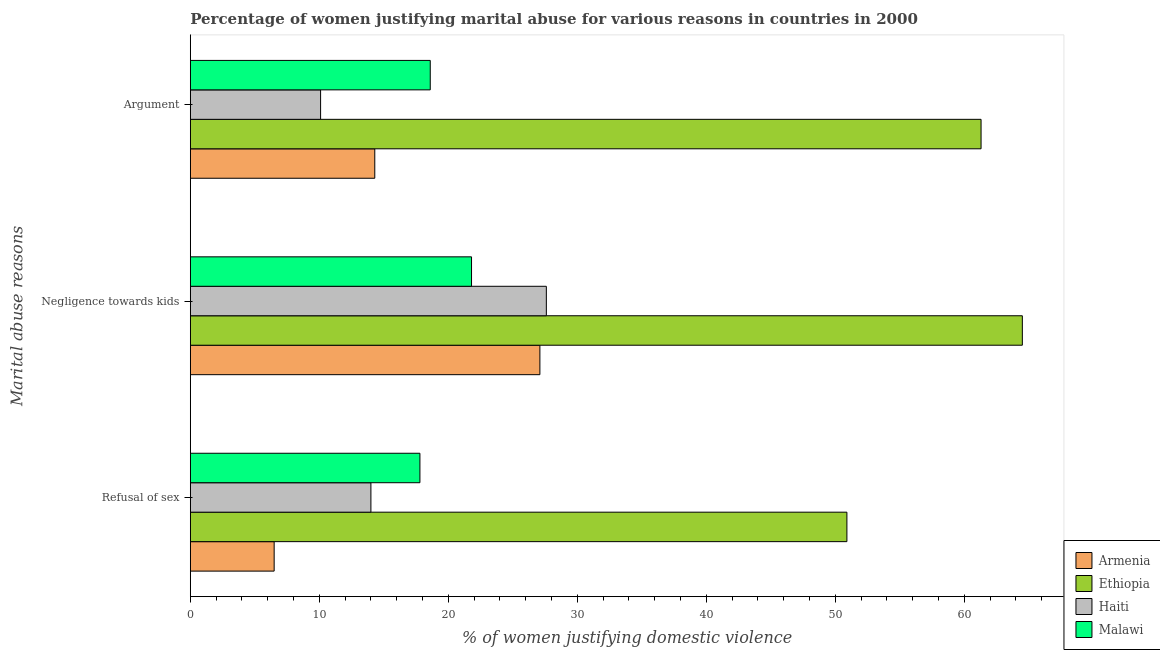How many different coloured bars are there?
Your answer should be very brief. 4. Are the number of bars per tick equal to the number of legend labels?
Offer a terse response. Yes. How many bars are there on the 2nd tick from the top?
Offer a terse response. 4. What is the label of the 1st group of bars from the top?
Provide a succinct answer. Argument. Across all countries, what is the maximum percentage of women justifying domestic violence due to refusal of sex?
Provide a succinct answer. 50.9. In which country was the percentage of women justifying domestic violence due to negligence towards kids maximum?
Your response must be concise. Ethiopia. In which country was the percentage of women justifying domestic violence due to arguments minimum?
Your response must be concise. Haiti. What is the total percentage of women justifying domestic violence due to arguments in the graph?
Provide a short and direct response. 104.3. What is the difference between the percentage of women justifying domestic violence due to refusal of sex in Ethiopia and that in Malawi?
Give a very brief answer. 33.1. What is the difference between the percentage of women justifying domestic violence due to refusal of sex in Haiti and the percentage of women justifying domestic violence due to arguments in Armenia?
Provide a short and direct response. -0.3. What is the average percentage of women justifying domestic violence due to refusal of sex per country?
Offer a terse response. 22.3. What is the difference between the percentage of women justifying domestic violence due to refusal of sex and percentage of women justifying domestic violence due to arguments in Ethiopia?
Keep it short and to the point. -10.4. In how many countries, is the percentage of women justifying domestic violence due to arguments greater than 16 %?
Your answer should be compact. 2. What is the ratio of the percentage of women justifying domestic violence due to arguments in Malawi to that in Haiti?
Your answer should be compact. 1.84. Is the difference between the percentage of women justifying domestic violence due to negligence towards kids in Armenia and Haiti greater than the difference between the percentage of women justifying domestic violence due to arguments in Armenia and Haiti?
Your response must be concise. No. What is the difference between the highest and the second highest percentage of women justifying domestic violence due to negligence towards kids?
Make the answer very short. 36.9. What is the difference between the highest and the lowest percentage of women justifying domestic violence due to refusal of sex?
Provide a succinct answer. 44.4. What does the 4th bar from the top in Negligence towards kids represents?
Make the answer very short. Armenia. What does the 3rd bar from the bottom in Argument represents?
Ensure brevity in your answer.  Haiti. Is it the case that in every country, the sum of the percentage of women justifying domestic violence due to refusal of sex and percentage of women justifying domestic violence due to negligence towards kids is greater than the percentage of women justifying domestic violence due to arguments?
Give a very brief answer. Yes. Are all the bars in the graph horizontal?
Make the answer very short. Yes. What is the difference between two consecutive major ticks on the X-axis?
Ensure brevity in your answer.  10. Does the graph contain grids?
Ensure brevity in your answer.  No. How are the legend labels stacked?
Offer a very short reply. Vertical. What is the title of the graph?
Your answer should be compact. Percentage of women justifying marital abuse for various reasons in countries in 2000. What is the label or title of the X-axis?
Your answer should be very brief. % of women justifying domestic violence. What is the label or title of the Y-axis?
Your answer should be very brief. Marital abuse reasons. What is the % of women justifying domestic violence in Armenia in Refusal of sex?
Keep it short and to the point. 6.5. What is the % of women justifying domestic violence of Ethiopia in Refusal of sex?
Keep it short and to the point. 50.9. What is the % of women justifying domestic violence in Armenia in Negligence towards kids?
Provide a succinct answer. 27.1. What is the % of women justifying domestic violence of Ethiopia in Negligence towards kids?
Provide a short and direct response. 64.5. What is the % of women justifying domestic violence in Haiti in Negligence towards kids?
Give a very brief answer. 27.6. What is the % of women justifying domestic violence of Malawi in Negligence towards kids?
Ensure brevity in your answer.  21.8. What is the % of women justifying domestic violence of Ethiopia in Argument?
Your answer should be compact. 61.3. What is the % of women justifying domestic violence in Haiti in Argument?
Ensure brevity in your answer.  10.1. What is the % of women justifying domestic violence of Malawi in Argument?
Provide a short and direct response. 18.6. Across all Marital abuse reasons, what is the maximum % of women justifying domestic violence of Armenia?
Your answer should be compact. 27.1. Across all Marital abuse reasons, what is the maximum % of women justifying domestic violence in Ethiopia?
Provide a succinct answer. 64.5. Across all Marital abuse reasons, what is the maximum % of women justifying domestic violence of Haiti?
Provide a succinct answer. 27.6. Across all Marital abuse reasons, what is the maximum % of women justifying domestic violence of Malawi?
Your response must be concise. 21.8. Across all Marital abuse reasons, what is the minimum % of women justifying domestic violence in Armenia?
Make the answer very short. 6.5. Across all Marital abuse reasons, what is the minimum % of women justifying domestic violence of Ethiopia?
Your response must be concise. 50.9. Across all Marital abuse reasons, what is the minimum % of women justifying domestic violence of Malawi?
Give a very brief answer. 17.8. What is the total % of women justifying domestic violence of Armenia in the graph?
Provide a short and direct response. 47.9. What is the total % of women justifying domestic violence in Ethiopia in the graph?
Make the answer very short. 176.7. What is the total % of women justifying domestic violence in Haiti in the graph?
Make the answer very short. 51.7. What is the total % of women justifying domestic violence of Malawi in the graph?
Provide a short and direct response. 58.2. What is the difference between the % of women justifying domestic violence of Armenia in Refusal of sex and that in Negligence towards kids?
Offer a terse response. -20.6. What is the difference between the % of women justifying domestic violence of Ethiopia in Refusal of sex and that in Negligence towards kids?
Give a very brief answer. -13.6. What is the difference between the % of women justifying domestic violence in Haiti in Refusal of sex and that in Negligence towards kids?
Provide a succinct answer. -13.6. What is the difference between the % of women justifying domestic violence in Malawi in Refusal of sex and that in Negligence towards kids?
Offer a terse response. -4. What is the difference between the % of women justifying domestic violence in Armenia in Refusal of sex and that in Argument?
Your answer should be very brief. -7.8. What is the difference between the % of women justifying domestic violence in Ethiopia in Refusal of sex and that in Argument?
Provide a succinct answer. -10.4. What is the difference between the % of women justifying domestic violence of Haiti in Refusal of sex and that in Argument?
Offer a very short reply. 3.9. What is the difference between the % of women justifying domestic violence in Malawi in Refusal of sex and that in Argument?
Make the answer very short. -0.8. What is the difference between the % of women justifying domestic violence of Armenia in Negligence towards kids and that in Argument?
Give a very brief answer. 12.8. What is the difference between the % of women justifying domestic violence of Ethiopia in Negligence towards kids and that in Argument?
Offer a terse response. 3.2. What is the difference between the % of women justifying domestic violence in Armenia in Refusal of sex and the % of women justifying domestic violence in Ethiopia in Negligence towards kids?
Provide a short and direct response. -58. What is the difference between the % of women justifying domestic violence of Armenia in Refusal of sex and the % of women justifying domestic violence of Haiti in Negligence towards kids?
Your answer should be compact. -21.1. What is the difference between the % of women justifying domestic violence of Armenia in Refusal of sex and the % of women justifying domestic violence of Malawi in Negligence towards kids?
Provide a short and direct response. -15.3. What is the difference between the % of women justifying domestic violence in Ethiopia in Refusal of sex and the % of women justifying domestic violence in Haiti in Negligence towards kids?
Your response must be concise. 23.3. What is the difference between the % of women justifying domestic violence of Ethiopia in Refusal of sex and the % of women justifying domestic violence of Malawi in Negligence towards kids?
Offer a very short reply. 29.1. What is the difference between the % of women justifying domestic violence of Armenia in Refusal of sex and the % of women justifying domestic violence of Ethiopia in Argument?
Provide a short and direct response. -54.8. What is the difference between the % of women justifying domestic violence in Armenia in Refusal of sex and the % of women justifying domestic violence in Malawi in Argument?
Your answer should be compact. -12.1. What is the difference between the % of women justifying domestic violence in Ethiopia in Refusal of sex and the % of women justifying domestic violence in Haiti in Argument?
Make the answer very short. 40.8. What is the difference between the % of women justifying domestic violence of Ethiopia in Refusal of sex and the % of women justifying domestic violence of Malawi in Argument?
Make the answer very short. 32.3. What is the difference between the % of women justifying domestic violence in Armenia in Negligence towards kids and the % of women justifying domestic violence in Ethiopia in Argument?
Ensure brevity in your answer.  -34.2. What is the difference between the % of women justifying domestic violence in Armenia in Negligence towards kids and the % of women justifying domestic violence in Haiti in Argument?
Give a very brief answer. 17. What is the difference between the % of women justifying domestic violence of Ethiopia in Negligence towards kids and the % of women justifying domestic violence of Haiti in Argument?
Provide a succinct answer. 54.4. What is the difference between the % of women justifying domestic violence in Ethiopia in Negligence towards kids and the % of women justifying domestic violence in Malawi in Argument?
Provide a succinct answer. 45.9. What is the average % of women justifying domestic violence in Armenia per Marital abuse reasons?
Make the answer very short. 15.97. What is the average % of women justifying domestic violence in Ethiopia per Marital abuse reasons?
Provide a succinct answer. 58.9. What is the average % of women justifying domestic violence of Haiti per Marital abuse reasons?
Offer a terse response. 17.23. What is the difference between the % of women justifying domestic violence in Armenia and % of women justifying domestic violence in Ethiopia in Refusal of sex?
Provide a succinct answer. -44.4. What is the difference between the % of women justifying domestic violence in Armenia and % of women justifying domestic violence in Haiti in Refusal of sex?
Offer a terse response. -7.5. What is the difference between the % of women justifying domestic violence of Ethiopia and % of women justifying domestic violence of Haiti in Refusal of sex?
Your response must be concise. 36.9. What is the difference between the % of women justifying domestic violence of Ethiopia and % of women justifying domestic violence of Malawi in Refusal of sex?
Offer a very short reply. 33.1. What is the difference between the % of women justifying domestic violence of Haiti and % of women justifying domestic violence of Malawi in Refusal of sex?
Your answer should be very brief. -3.8. What is the difference between the % of women justifying domestic violence in Armenia and % of women justifying domestic violence in Ethiopia in Negligence towards kids?
Your answer should be very brief. -37.4. What is the difference between the % of women justifying domestic violence of Armenia and % of women justifying domestic violence of Malawi in Negligence towards kids?
Offer a very short reply. 5.3. What is the difference between the % of women justifying domestic violence of Ethiopia and % of women justifying domestic violence of Haiti in Negligence towards kids?
Give a very brief answer. 36.9. What is the difference between the % of women justifying domestic violence in Ethiopia and % of women justifying domestic violence in Malawi in Negligence towards kids?
Provide a short and direct response. 42.7. What is the difference between the % of women justifying domestic violence in Armenia and % of women justifying domestic violence in Ethiopia in Argument?
Give a very brief answer. -47. What is the difference between the % of women justifying domestic violence in Armenia and % of women justifying domestic violence in Haiti in Argument?
Make the answer very short. 4.2. What is the difference between the % of women justifying domestic violence in Armenia and % of women justifying domestic violence in Malawi in Argument?
Keep it short and to the point. -4.3. What is the difference between the % of women justifying domestic violence of Ethiopia and % of women justifying domestic violence of Haiti in Argument?
Provide a short and direct response. 51.2. What is the difference between the % of women justifying domestic violence of Ethiopia and % of women justifying domestic violence of Malawi in Argument?
Keep it short and to the point. 42.7. What is the ratio of the % of women justifying domestic violence in Armenia in Refusal of sex to that in Negligence towards kids?
Offer a terse response. 0.24. What is the ratio of the % of women justifying domestic violence of Ethiopia in Refusal of sex to that in Negligence towards kids?
Give a very brief answer. 0.79. What is the ratio of the % of women justifying domestic violence in Haiti in Refusal of sex to that in Negligence towards kids?
Give a very brief answer. 0.51. What is the ratio of the % of women justifying domestic violence in Malawi in Refusal of sex to that in Negligence towards kids?
Your answer should be very brief. 0.82. What is the ratio of the % of women justifying domestic violence in Armenia in Refusal of sex to that in Argument?
Make the answer very short. 0.45. What is the ratio of the % of women justifying domestic violence of Ethiopia in Refusal of sex to that in Argument?
Your answer should be very brief. 0.83. What is the ratio of the % of women justifying domestic violence in Haiti in Refusal of sex to that in Argument?
Your response must be concise. 1.39. What is the ratio of the % of women justifying domestic violence of Malawi in Refusal of sex to that in Argument?
Give a very brief answer. 0.96. What is the ratio of the % of women justifying domestic violence of Armenia in Negligence towards kids to that in Argument?
Give a very brief answer. 1.9. What is the ratio of the % of women justifying domestic violence of Ethiopia in Negligence towards kids to that in Argument?
Your answer should be compact. 1.05. What is the ratio of the % of women justifying domestic violence in Haiti in Negligence towards kids to that in Argument?
Give a very brief answer. 2.73. What is the ratio of the % of women justifying domestic violence of Malawi in Negligence towards kids to that in Argument?
Give a very brief answer. 1.17. What is the difference between the highest and the second highest % of women justifying domestic violence in Armenia?
Provide a succinct answer. 12.8. What is the difference between the highest and the second highest % of women justifying domestic violence of Ethiopia?
Ensure brevity in your answer.  3.2. What is the difference between the highest and the second highest % of women justifying domestic violence in Haiti?
Keep it short and to the point. 13.6. What is the difference between the highest and the lowest % of women justifying domestic violence of Armenia?
Your answer should be very brief. 20.6. What is the difference between the highest and the lowest % of women justifying domestic violence in Haiti?
Your response must be concise. 17.5. What is the difference between the highest and the lowest % of women justifying domestic violence in Malawi?
Offer a terse response. 4. 